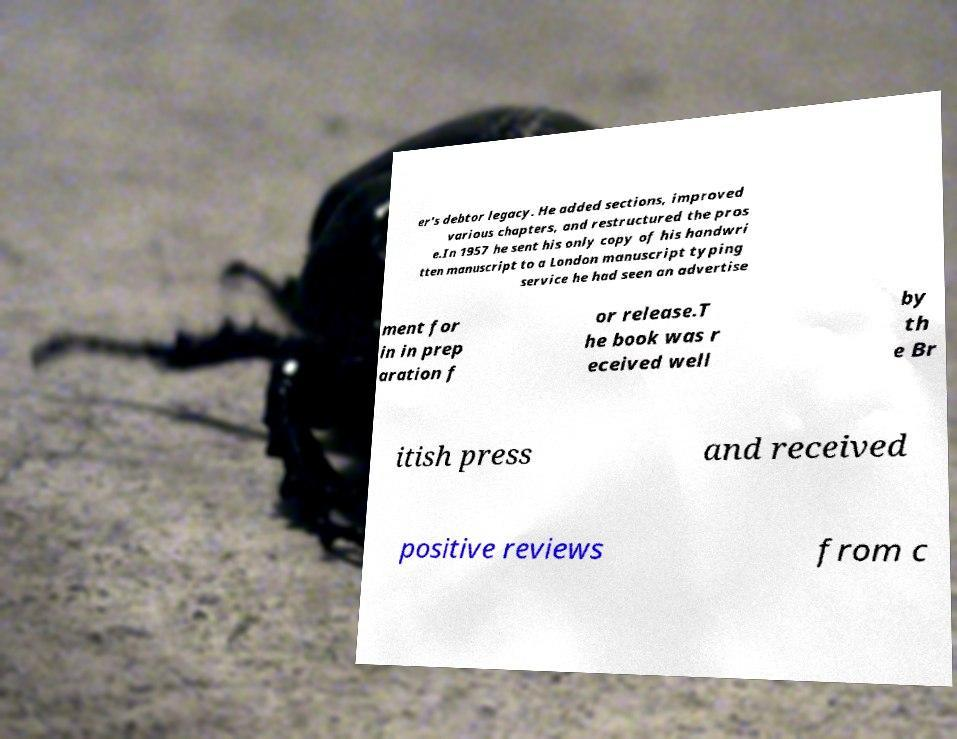What messages or text are displayed in this image? I need them in a readable, typed format. er's debtor legacy. He added sections, improved various chapters, and restructured the pros e.In 1957 he sent his only copy of his handwri tten manuscript to a London manuscript typing service he had seen an advertise ment for in in prep aration f or release.T he book was r eceived well by th e Br itish press and received positive reviews from c 